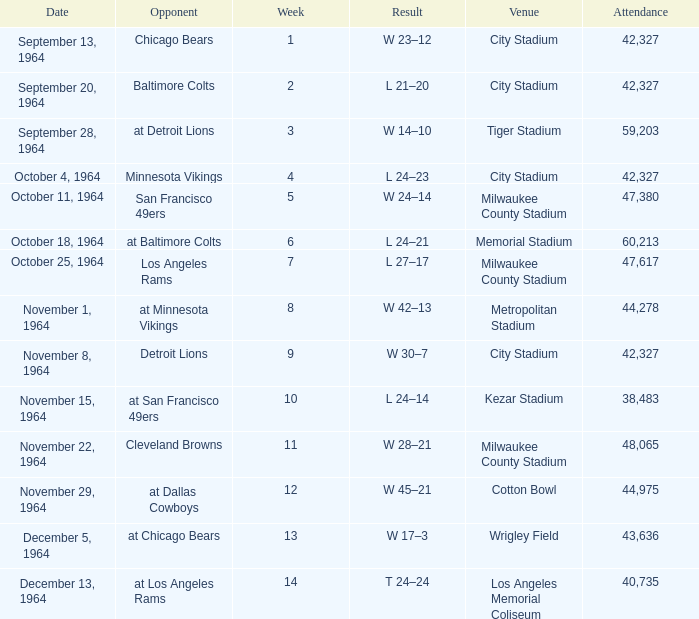What is the average attendance at a week 4 game? 42327.0. 